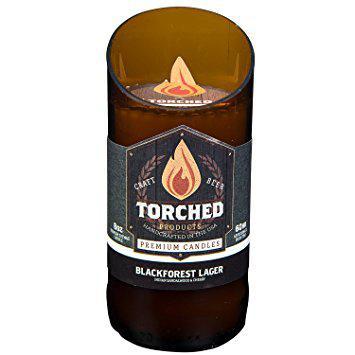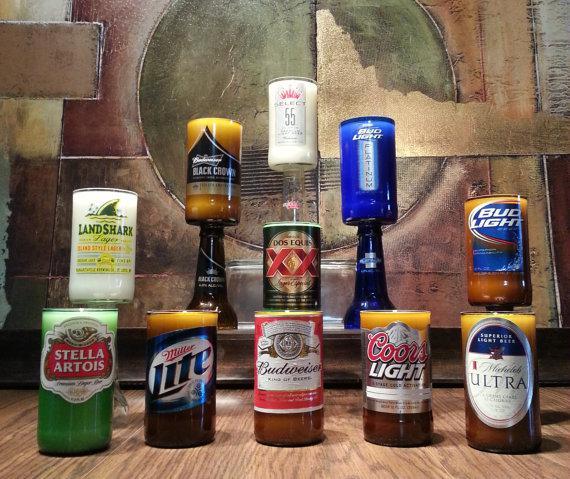The first image is the image on the left, the second image is the image on the right. For the images displayed, is the sentence "There are less than four bottles in one of the pictures." factually correct? Answer yes or no. Yes. 